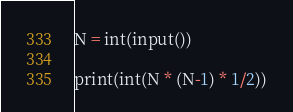<code> <loc_0><loc_0><loc_500><loc_500><_Python_>N = int(input())

print(int(N * (N-1) * 1/2))</code> 